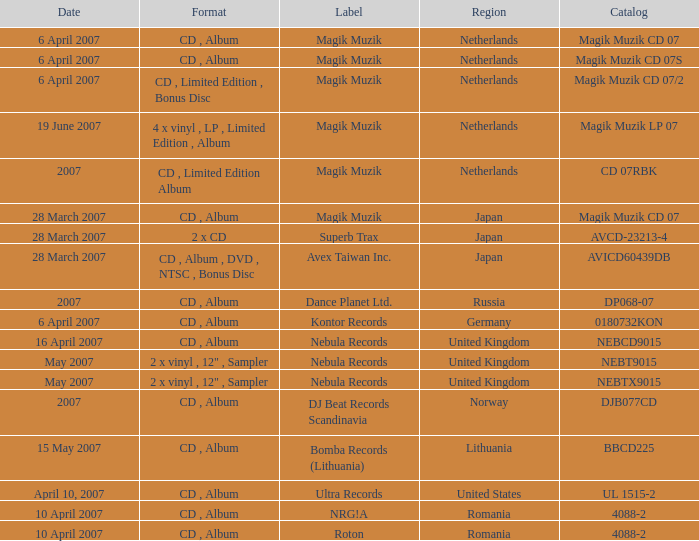From which region is the album with release date of 19 June 2007? Netherlands. 